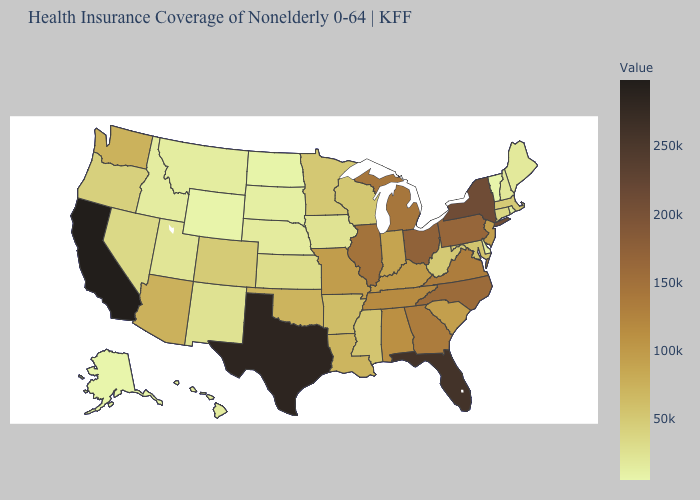Among the states that border New Jersey , does Delaware have the lowest value?
Write a very short answer. Yes. Does Mississippi have a lower value than South Carolina?
Be succinct. Yes. Among the states that border Wisconsin , does Michigan have the highest value?
Write a very short answer. No. Does Arizona have a lower value than Nevada?
Answer briefly. No. Which states have the highest value in the USA?
Short answer required. California. 